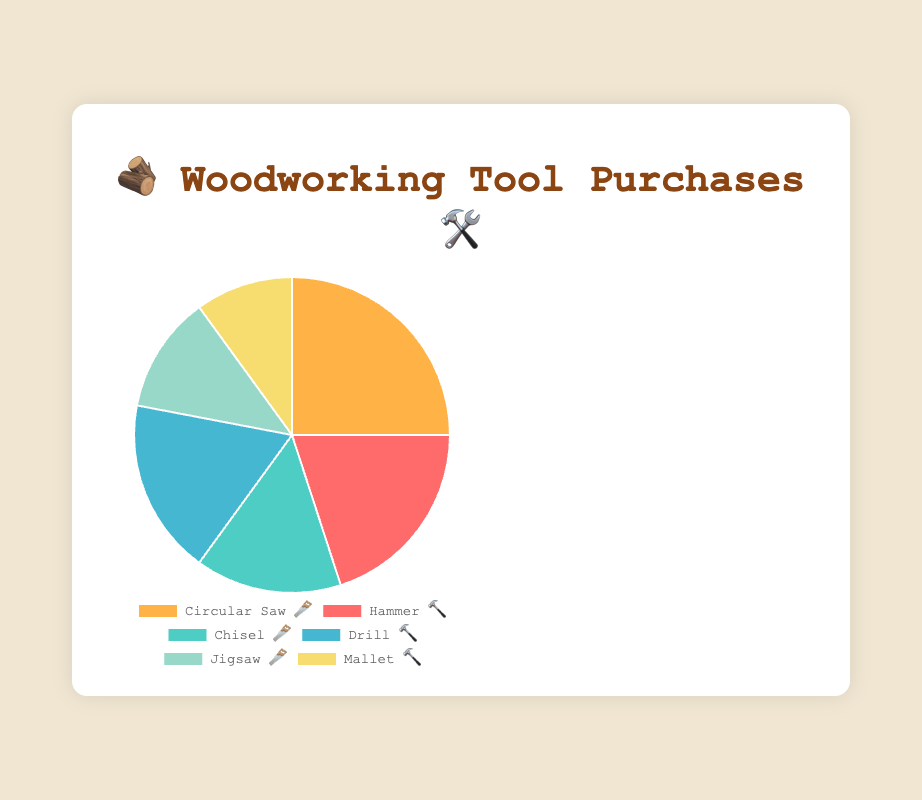Which tool is purchased the most by hobbyists? The Circular Saw 🪚 has the highest percentage at 25%, making it the most purchased tool.
Answer: Circular Saw 🪚 What percentage of purchases do the Chisel 🪚 and Jigsaw 🪚 together account for? The Chisel 🪚 accounts for 15% and the Jigsaw 🪚 accounts for 12%. Adding these together gives 15% + 12% = 27%.
Answer: 27% How much more popular is the Circular Saw 🪚 compared to the Mallet 🔨? The Circular Saw 🪚 is at 25%, while the Mallet 🔨 is at 10%. The difference is 25% - 10% = 15%.
Answer: 15% What is the combined total percentage of Hammer 🔨 and Drill 🔨 purchases? The Hammer 🔨 accounts for 20% and the Drill 🔨 accounts for 18%. Adding these together gives 20% + 18% = 38%.
Answer: 38% Rank the tools from most purchased to least purchased. The percentages in descending order are: Circular Saw 🪚 (25%), Hammer 🔨 (20%), Drill 🔨 (18%), Chisel 🪚 (15%), Jigsaw 🪚 (12%), Mallet 🔨 (10%).
Answer: Circular Saw 🪚, Hammer 🔨, Drill 🔨, Chisel 🪚, Jigsaw 🪚, Mallet 🔨 Which tool is purchased the least by hobbyists? The Mallet 🔨 has the lowest percentage at 10%, making it the least purchased tool.
Answer: Mallet 🔨 What is the average percentage of tool purchases across all categories? The total percentage is 100%, and there are 6 categories. The average is 100% / 6 = approximately 16.67%.
Answer: 16.67% If the percentage for Chisel 🪚 increased by 5%, what would the new percentage be? The current percentage for the Chisel 🪚 is 15%. Adding 5% gives 15% + 5% = 20%.
Answer: 20% 